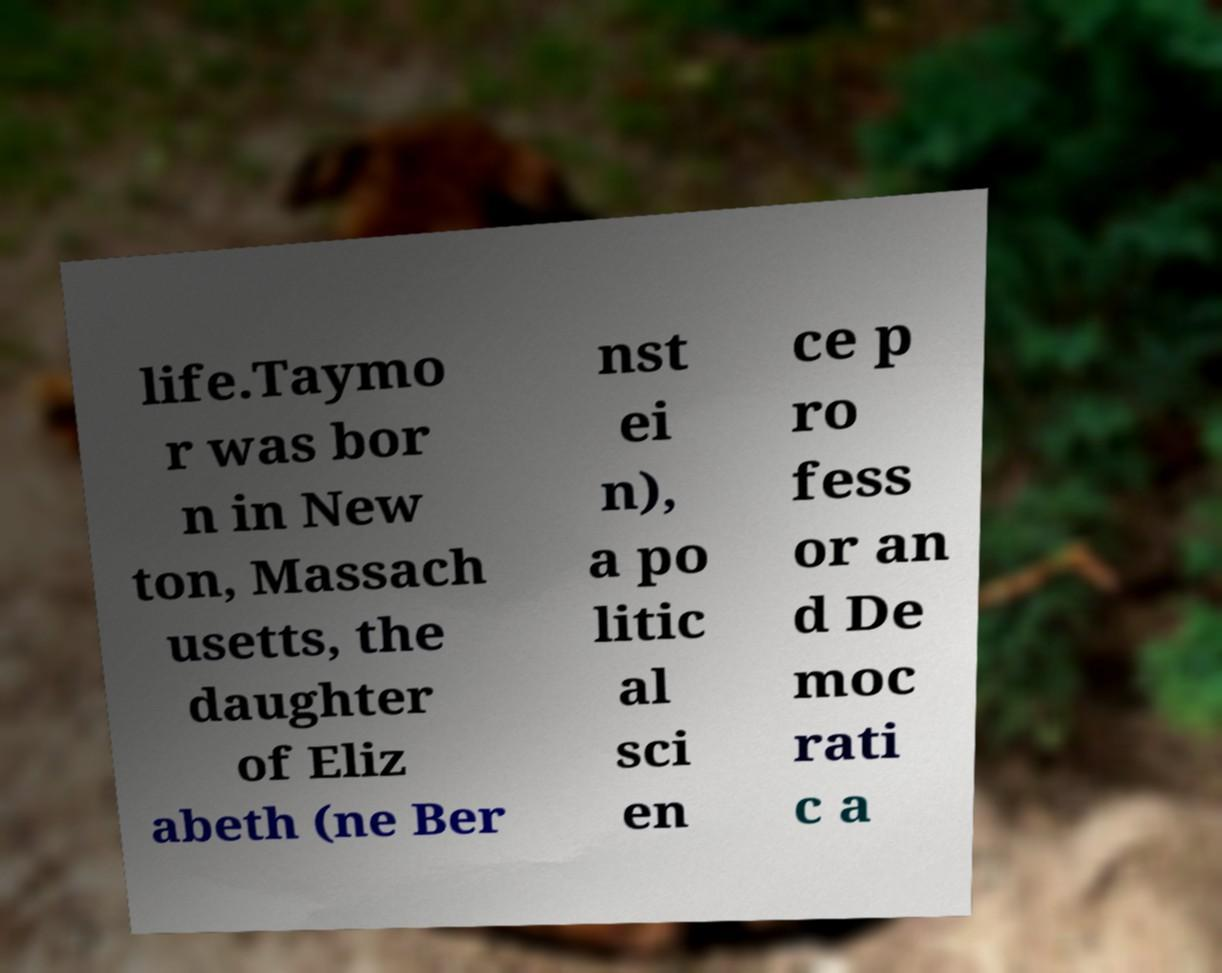What messages or text are displayed in this image? I need them in a readable, typed format. life.Taymo r was bor n in New ton, Massach usetts, the daughter of Eliz abeth (ne Ber nst ei n), a po litic al sci en ce p ro fess or an d De moc rati c a 